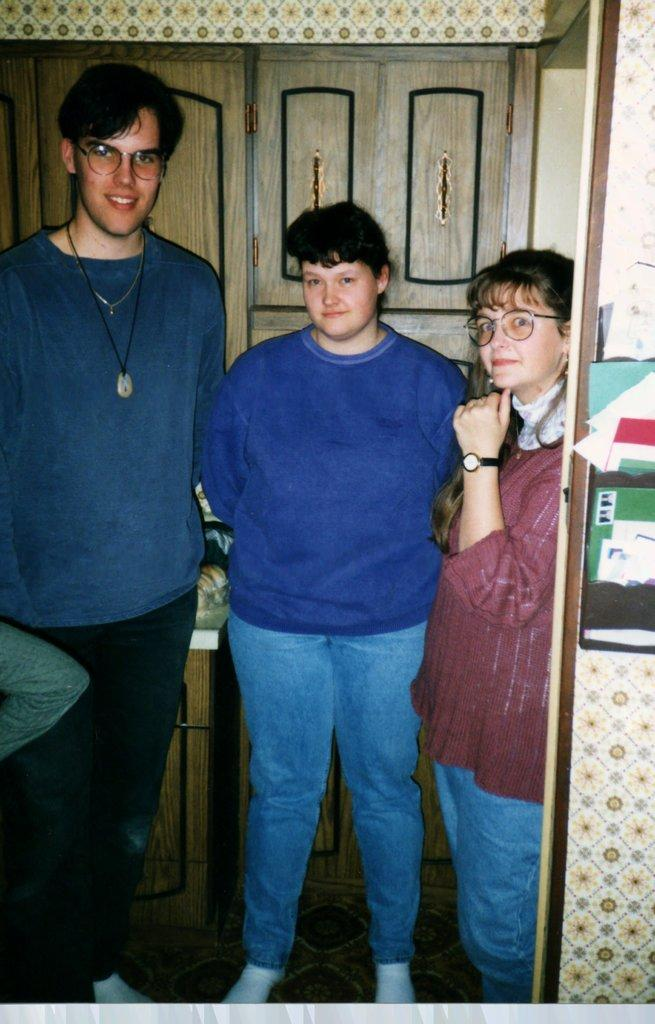How many people are in the image? There are three persons in the image. What are the persons wearing? The persons are wearing clothes. What can be seen behind the persons in the image? The persons are standing in front of a cupboard. What type of copper object can be seen in the hands of the persons in the image? There is no copper object present in the image; the persons are not holding anything. 